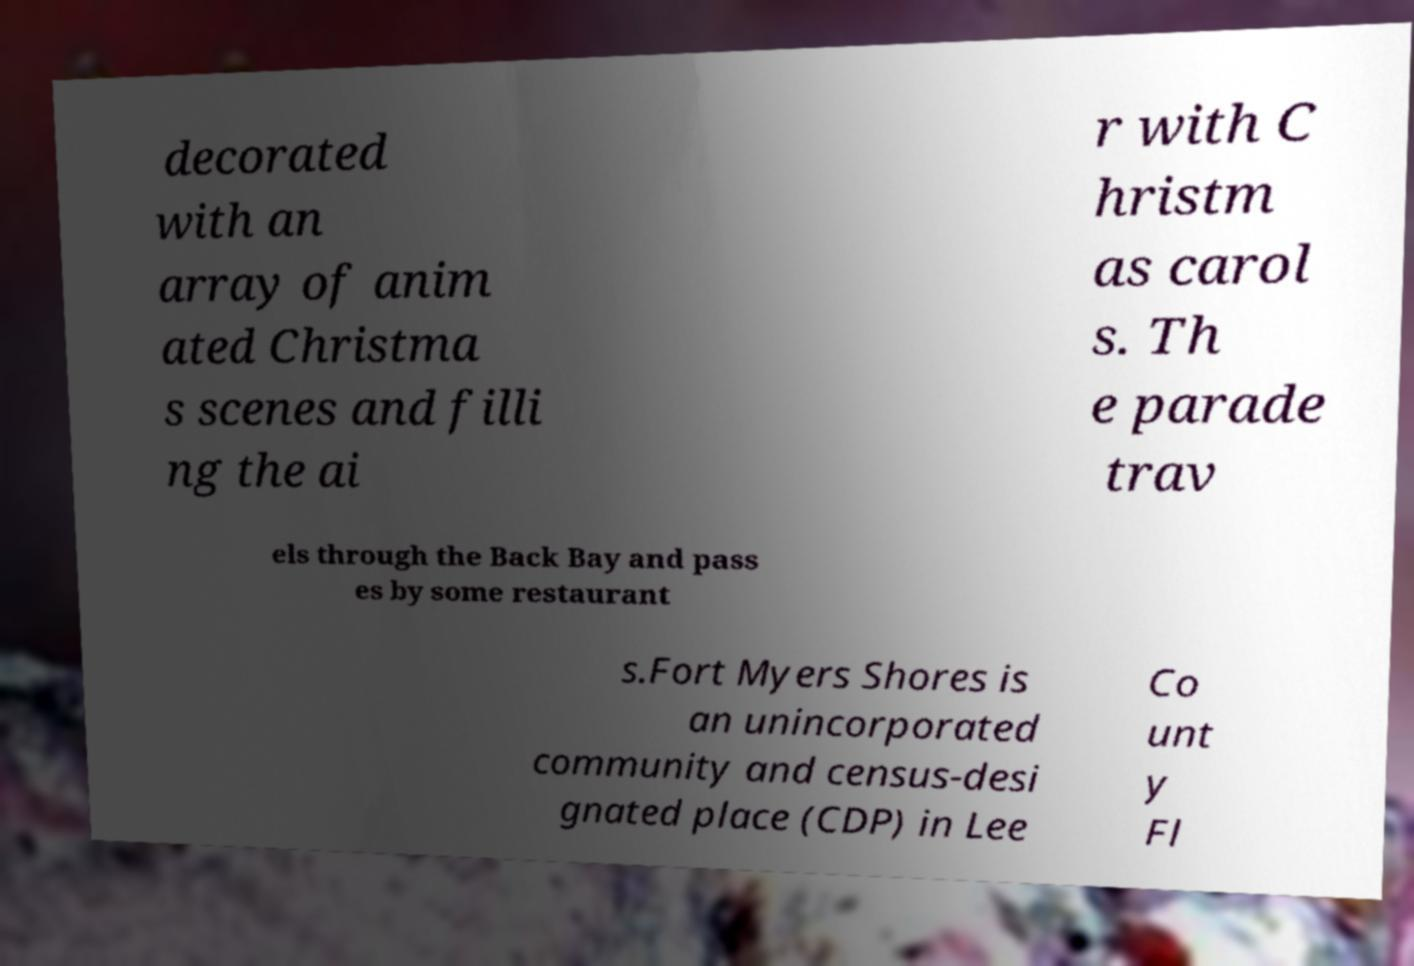Can you read and provide the text displayed in the image?This photo seems to have some interesting text. Can you extract and type it out for me? decorated with an array of anim ated Christma s scenes and filli ng the ai r with C hristm as carol s. Th e parade trav els through the Back Bay and pass es by some restaurant s.Fort Myers Shores is an unincorporated community and census-desi gnated place (CDP) in Lee Co unt y Fl 